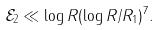Convert formula to latex. <formula><loc_0><loc_0><loc_500><loc_500>\mathcal { E } _ { 2 } \ll \log R ( \log R / R _ { 1 } ) ^ { 7 } .</formula> 